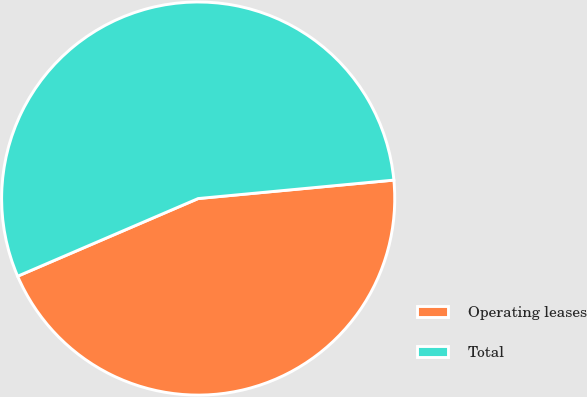Convert chart to OTSL. <chart><loc_0><loc_0><loc_500><loc_500><pie_chart><fcel>Operating leases<fcel>Total<nl><fcel>45.03%<fcel>54.97%<nl></chart> 